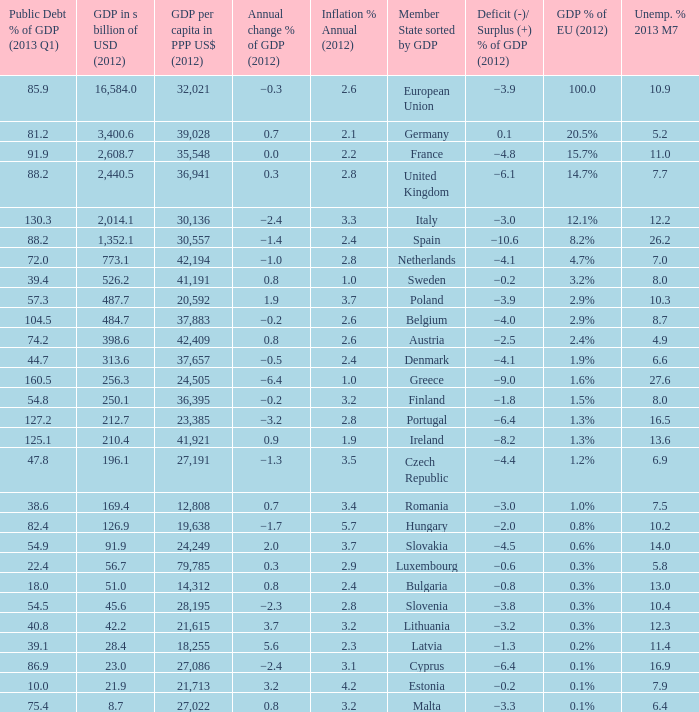What is the deficit/surplus % of the 2012 GDP of the country with a GDP in billions of USD in 2012 less than 1,352.1, a GDP per capita in PPP US dollars in 2012 greater than 21,615, public debt % of GDP in the 2013 Q1 less than 75.4, and an inflation % annual in 2012 of 2.9? −0.6. 